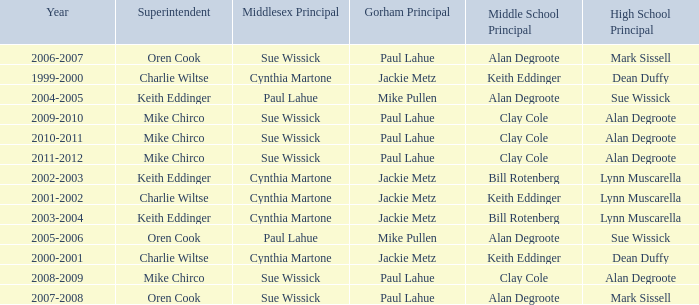Who were the middle school principal(s) in 2010-2011? Clay Cole. 